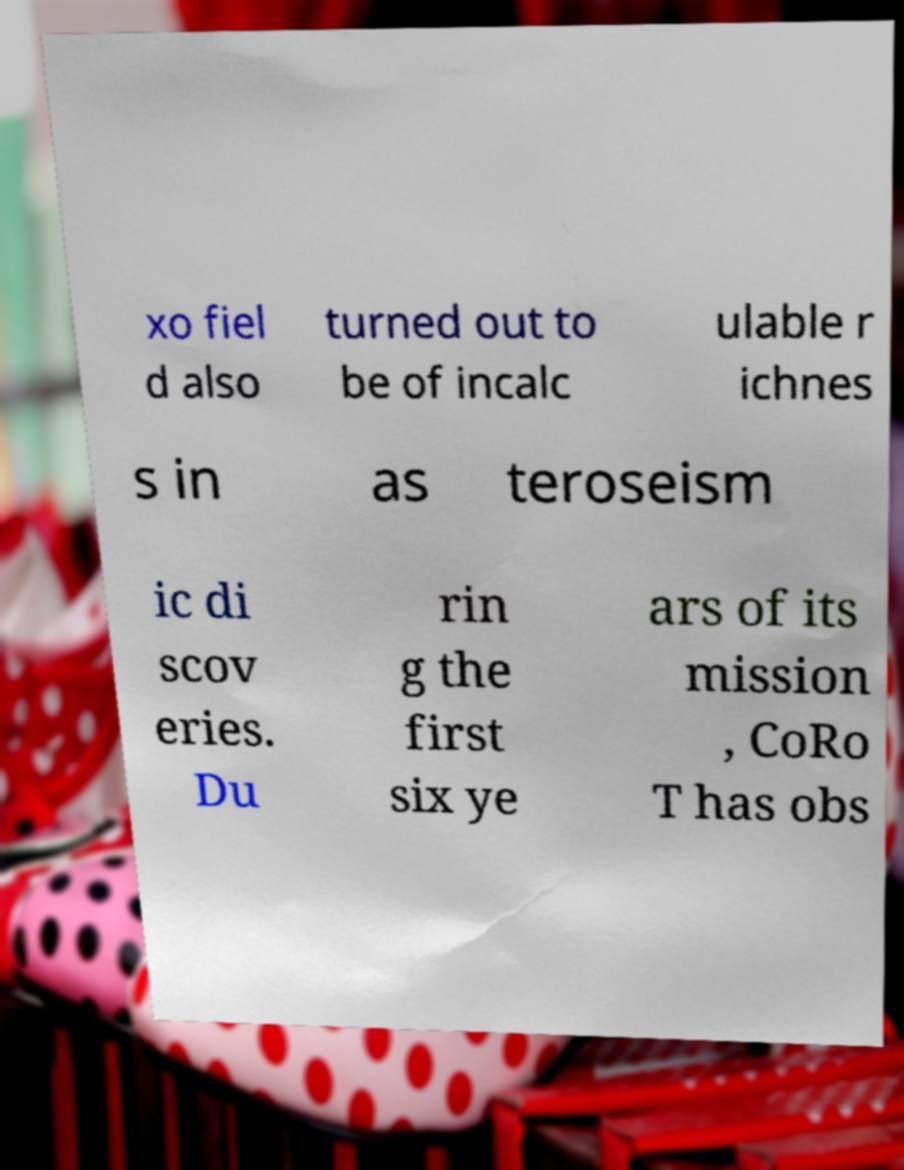Please read and relay the text visible in this image. What does it say? xo fiel d also turned out to be of incalc ulable r ichnes s in as teroseism ic di scov eries. Du rin g the first six ye ars of its mission , CoRo T has obs 